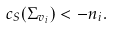Convert formula to latex. <formula><loc_0><loc_0><loc_500><loc_500>c _ { S } ( \Sigma _ { v _ { i } } ) < - n _ { i } .</formula> 